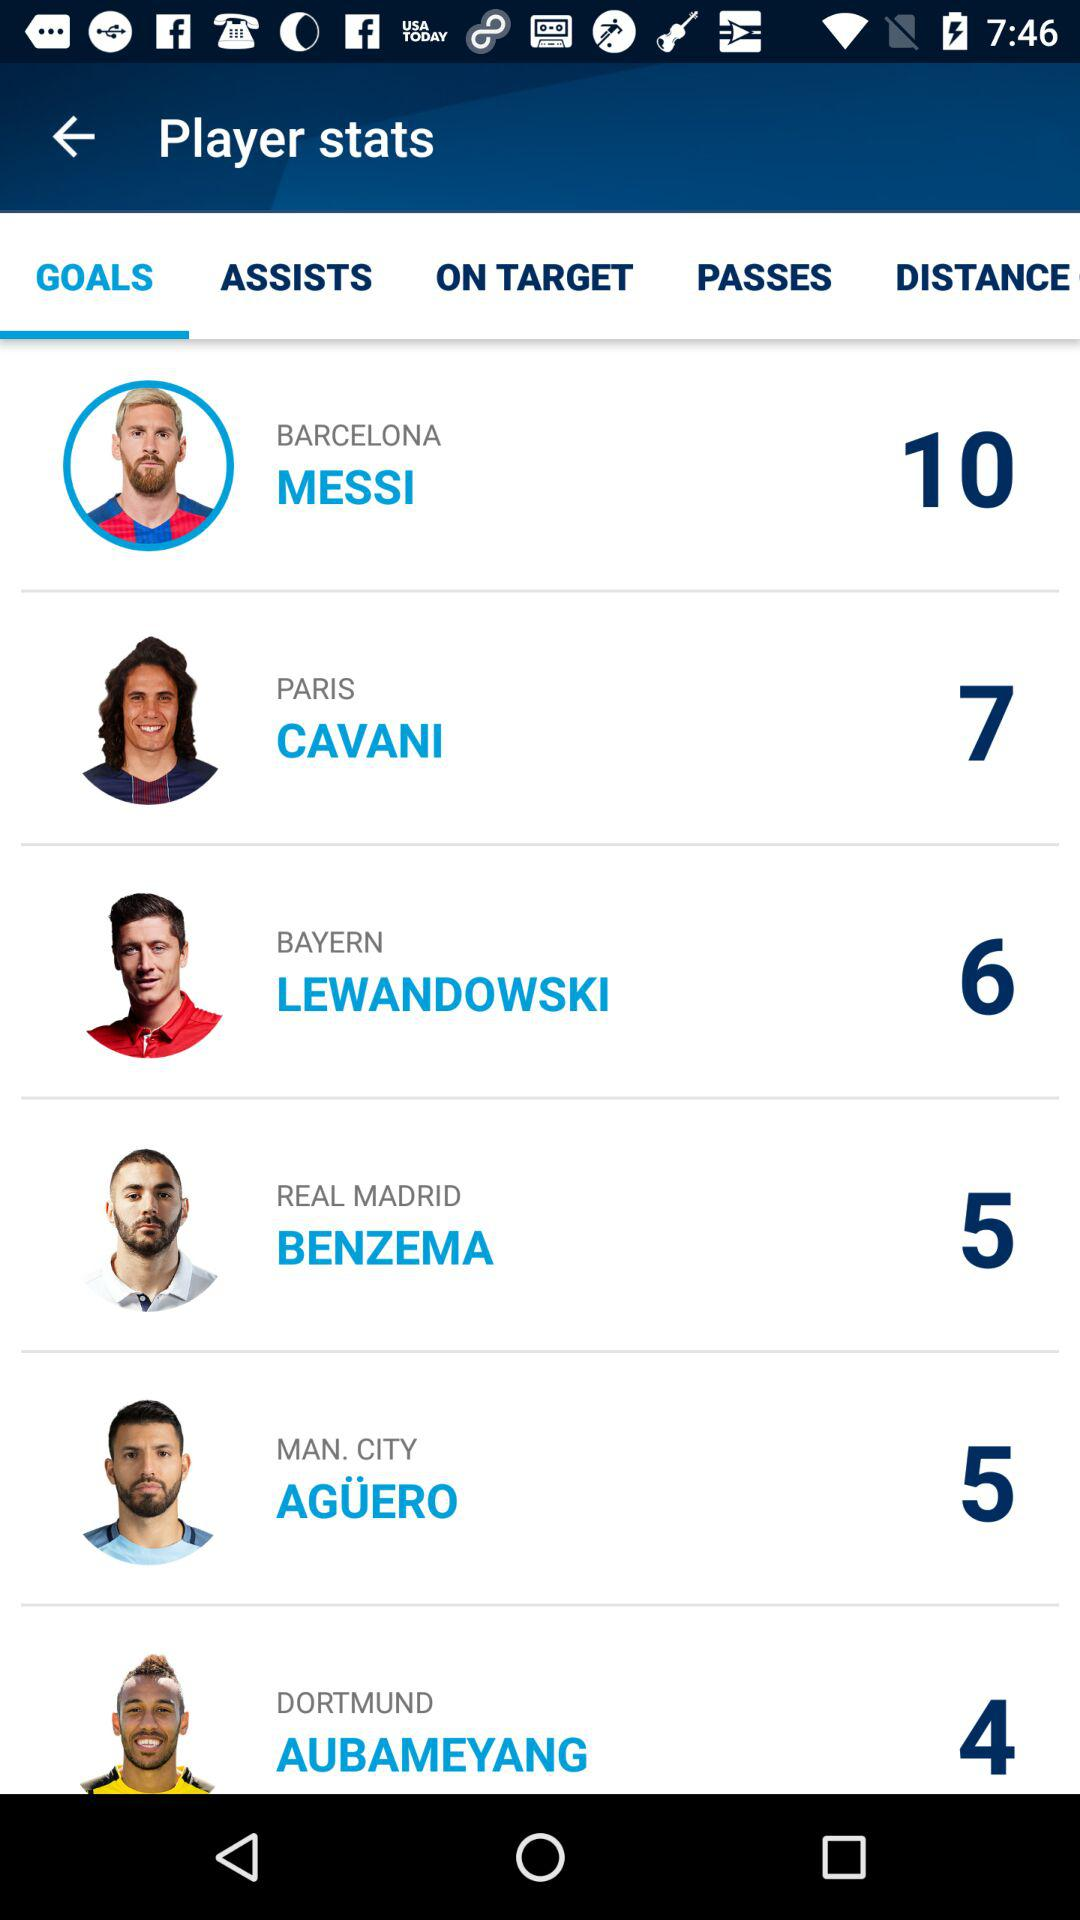Cavani belongs to which city? Cavani belongs to Paris. 